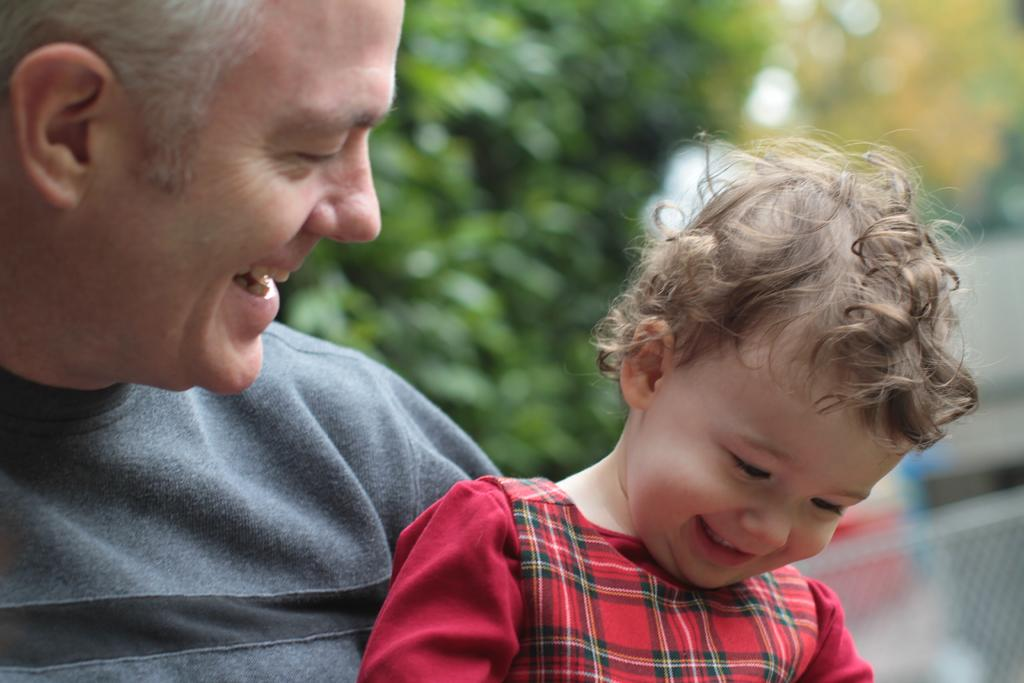Who is present in the image? There is a man and a kid in the image. What is the man doing in the image? The man is smiling and looking at the kid. What is the kid doing in the image? The kid is smiling and looking downwards. What can be seen in the background of the image? The background of the image is blurred, and there are trees and a mesh visible. What type of quill is the man using to write a letter in the image? There is no quill or writing activity present in the image. Is the kid taking a bath in the image? No, the kid is not taking a bath in the image; they are standing and looking downwards. 